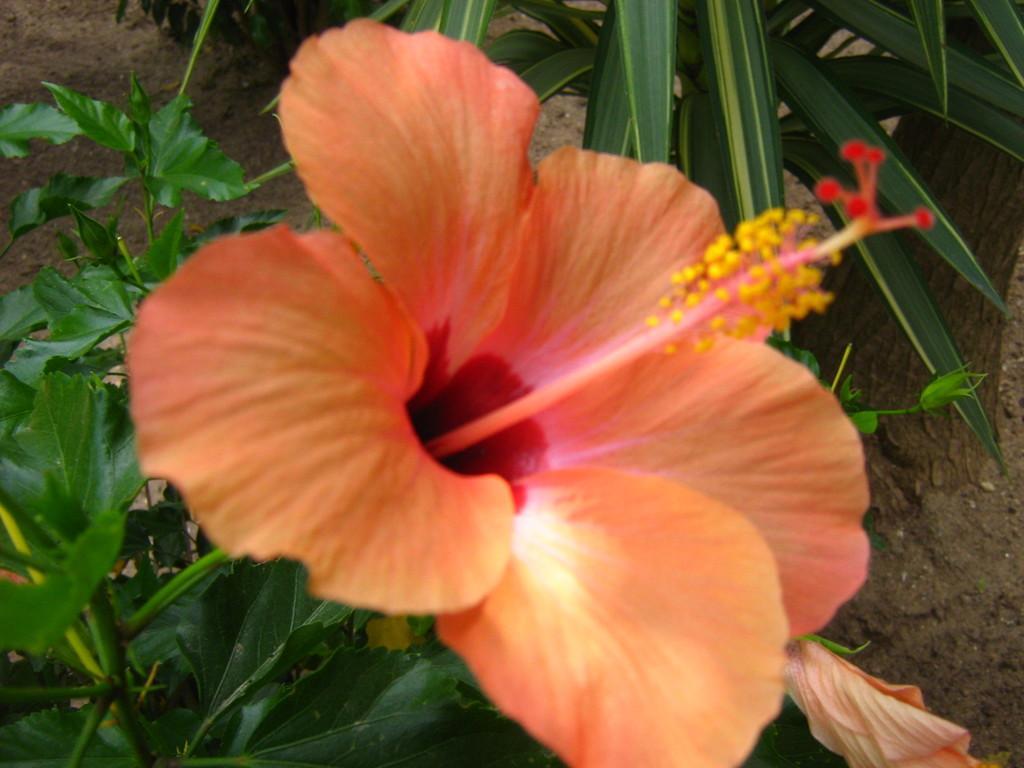Describe this image in one or two sentences. In this image, we can see an orange color flower and we can see some green leaves. 